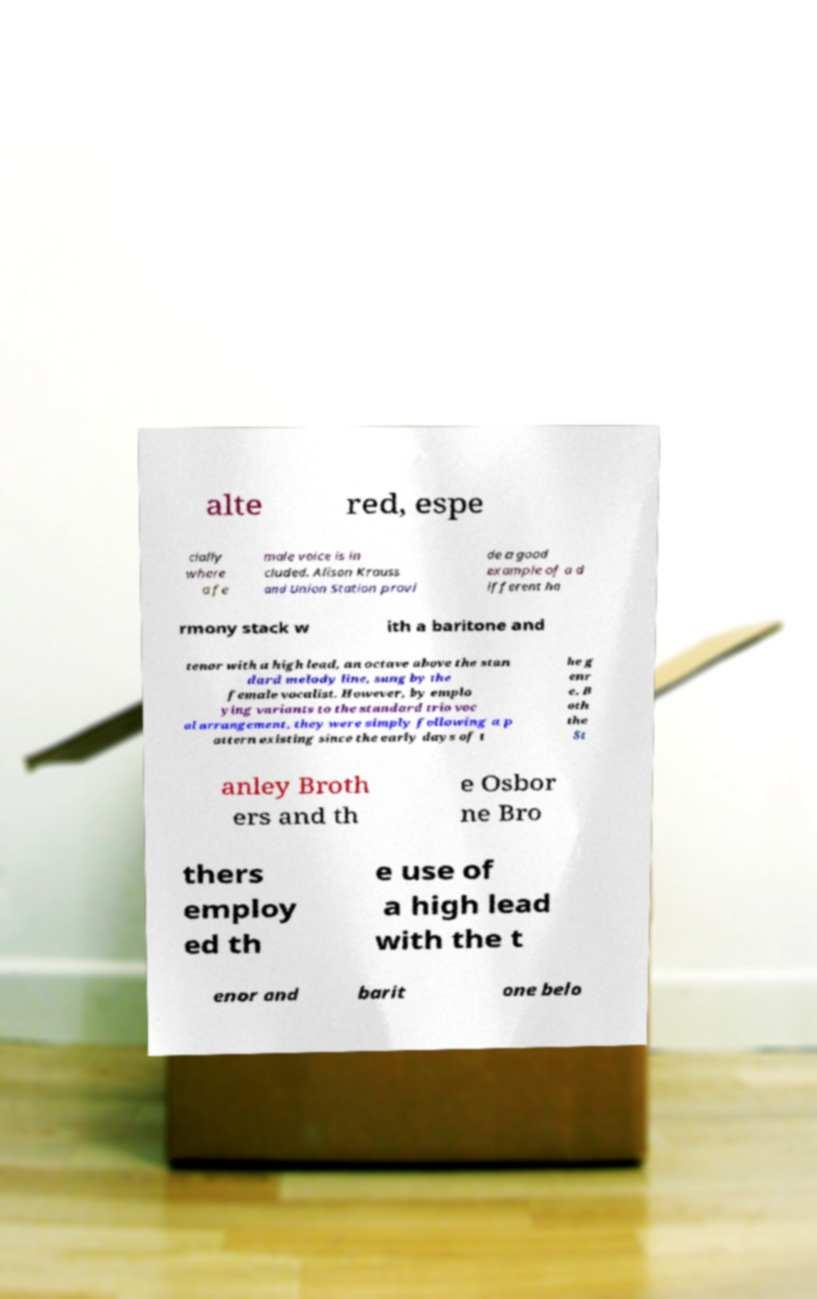Can you accurately transcribe the text from the provided image for me? alte red, espe cially where a fe male voice is in cluded. Alison Krauss and Union Station provi de a good example of a d ifferent ha rmony stack w ith a baritone and tenor with a high lead, an octave above the stan dard melody line, sung by the female vocalist. However, by emplo ying variants to the standard trio voc al arrangement, they were simply following a p attern existing since the early days of t he g enr e. B oth the St anley Broth ers and th e Osbor ne Bro thers employ ed th e use of a high lead with the t enor and barit one belo 